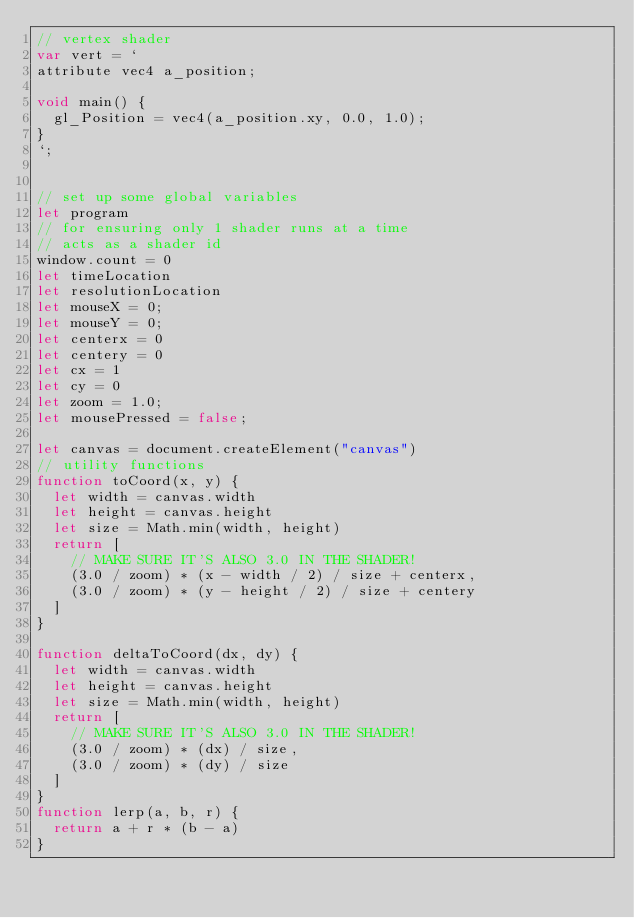Convert code to text. <code><loc_0><loc_0><loc_500><loc_500><_JavaScript_>// vertex shader
var vert = `
attribute vec4 a_position;

void main() {
  gl_Position = vec4(a_position.xy, 0.0, 1.0);
}
`;


// set up some global variables
let program
// for ensuring only 1 shader runs at a time
// acts as a shader id
window.count = 0
let timeLocation
let resolutionLocation
let mouseX = 0;
let mouseY = 0;
let centerx = 0
let centery = 0
let cx = 1
let cy = 0
let zoom = 1.0;
let mousePressed = false;

let canvas = document.createElement("canvas")
// utility functions
function toCoord(x, y) {
  let width = canvas.width
  let height = canvas.height
  let size = Math.min(width, height)
  return [
    // MAKE SURE IT'S ALSO 3.0 IN THE SHADER!
    (3.0 / zoom) * (x - width / 2) / size + centerx,
    (3.0 / zoom) * (y - height / 2) / size + centery
  ]
}

function deltaToCoord(dx, dy) {
  let width = canvas.width
  let height = canvas.height
  let size = Math.min(width, height)
  return [
    // MAKE SURE IT'S ALSO 3.0 IN THE SHADER!
    (3.0 / zoom) * (dx) / size,
    (3.0 / zoom) * (dy) / size
  ]
}
function lerp(a, b, r) {
  return a + r * (b - a)
}
</code> 